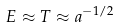Convert formula to latex. <formula><loc_0><loc_0><loc_500><loc_500>E \approx T \approx a ^ { - 1 / 2 }</formula> 